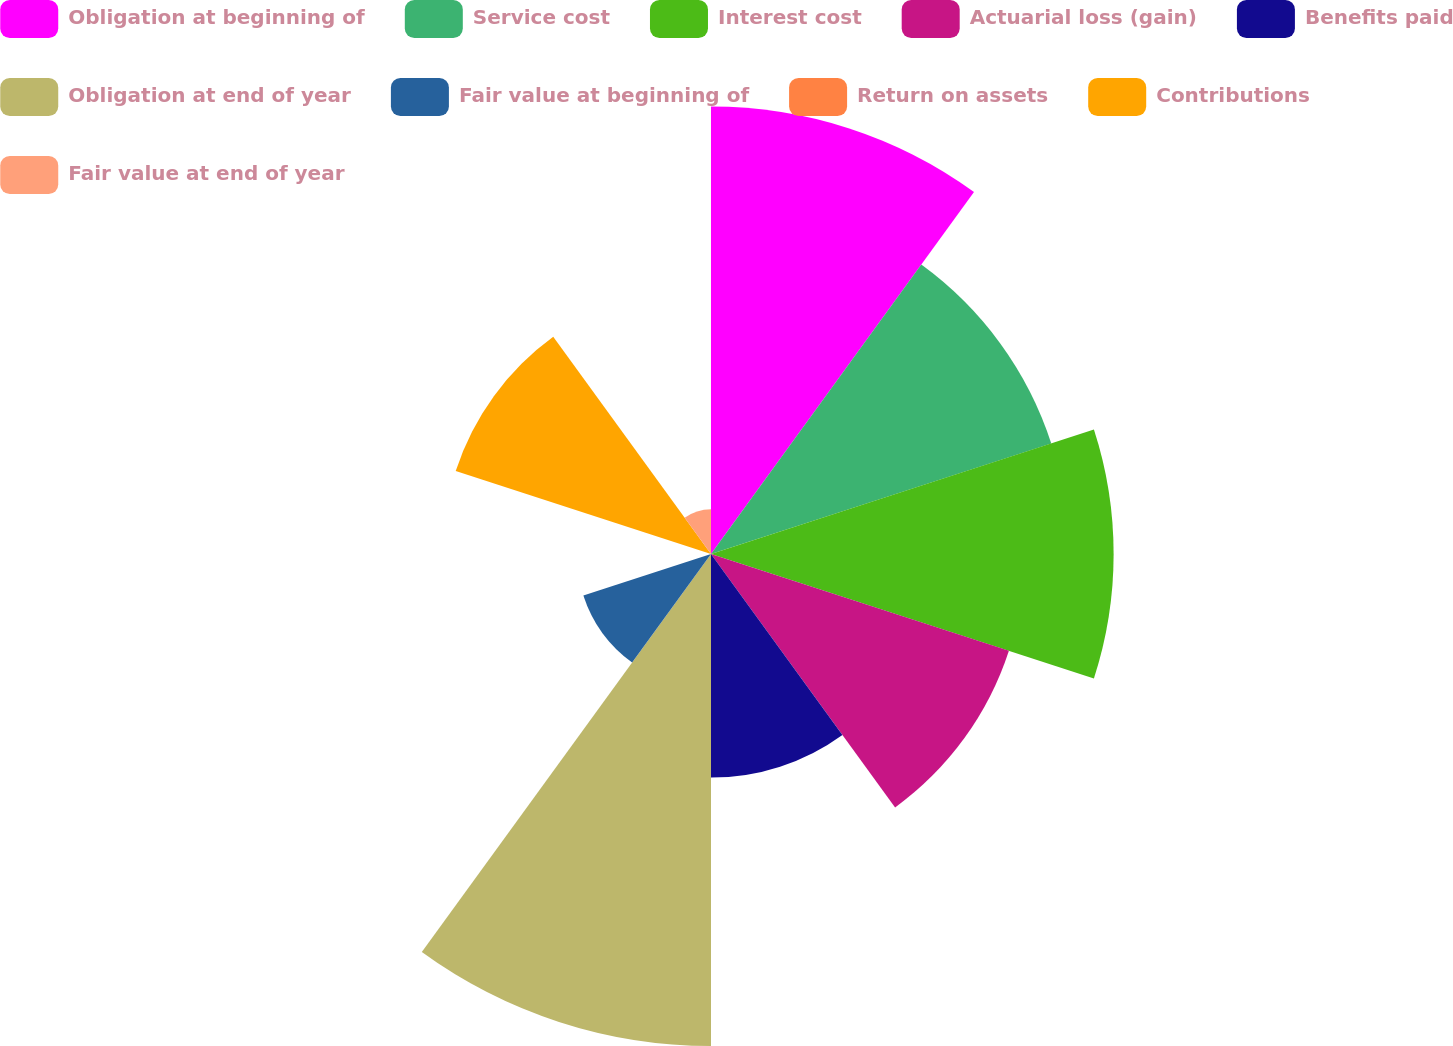Convert chart to OTSL. <chart><loc_0><loc_0><loc_500><loc_500><pie_chart><fcel>Obligation at beginning of<fcel>Service cost<fcel>Interest cost<fcel>Actuarial loss (gain)<fcel>Benefits paid<fcel>Obligation at end of year<fcel>Fair value at beginning of<fcel>Return on assets<fcel>Contributions<fcel>Fair value at end of year<nl><fcel>16.67%<fcel>13.33%<fcel>15.0%<fcel>11.67%<fcel>8.33%<fcel>18.33%<fcel>5.0%<fcel>0.0%<fcel>10.0%<fcel>1.67%<nl></chart> 